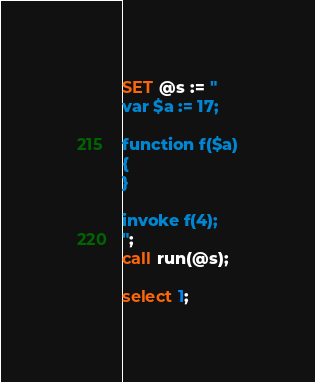Convert code to text. <code><loc_0><loc_0><loc_500><loc_500><_SQL_>SET @s := "
var $a := 17;

function f($a)
{
}

invoke f(4);
";
call run(@s);

select 1;
</code> 